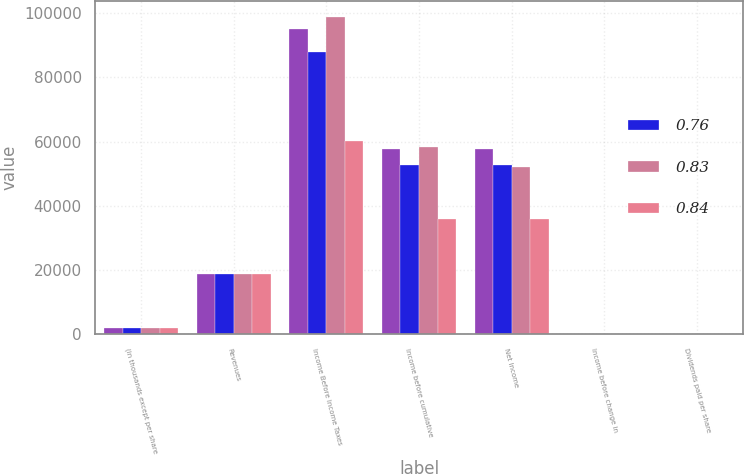<chart> <loc_0><loc_0><loc_500><loc_500><stacked_bar_chart><ecel><fcel>(in thousands except per share<fcel>Revenues<fcel>Income Before Income Taxes<fcel>Income before cumulative<fcel>Net Income<fcel>Income before change in<fcel>Dividends paid per share<nl><fcel>nan<fcel>2006<fcel>18883.5<fcel>95159<fcel>57809<fcel>57809<fcel>0.86<fcel>0.25<nl><fcel>0.76<fcel>2005<fcel>18883.5<fcel>87955<fcel>52773<fcel>52773<fcel>0.78<fcel>0.2<nl><fcel>0.83<fcel>2004<fcel>18883.5<fcel>98712<fcel>58259<fcel>52055<fcel>0.85<fcel>0.16<nl><fcel>0.84<fcel>2003<fcel>18883.5<fcel>60030<fcel>35761<fcel>35761<fcel>0.53<fcel>0.13<nl></chart> 